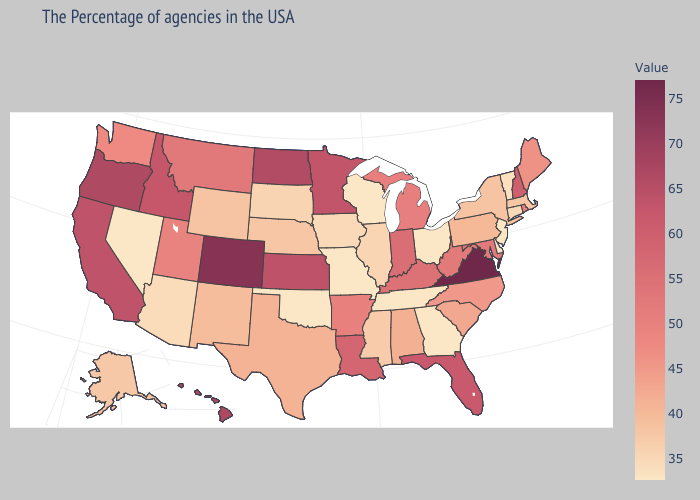Which states have the highest value in the USA?
Answer briefly. Virginia. Does Kansas have a lower value than West Virginia?
Quick response, please. No. Does Arizona have the lowest value in the USA?
Short answer required. No. Which states have the highest value in the USA?
Be succinct. Virginia. Is the legend a continuous bar?
Be succinct. Yes. Does Utah have the lowest value in the USA?
Give a very brief answer. No. Does Vermont have the highest value in the Northeast?
Give a very brief answer. No. Does Montana have the highest value in the USA?
Keep it brief. No. Which states have the lowest value in the USA?
Keep it brief. New Jersey, Delaware, Ohio, Georgia, Tennessee, Wisconsin, Missouri, Oklahoma, Nevada. 